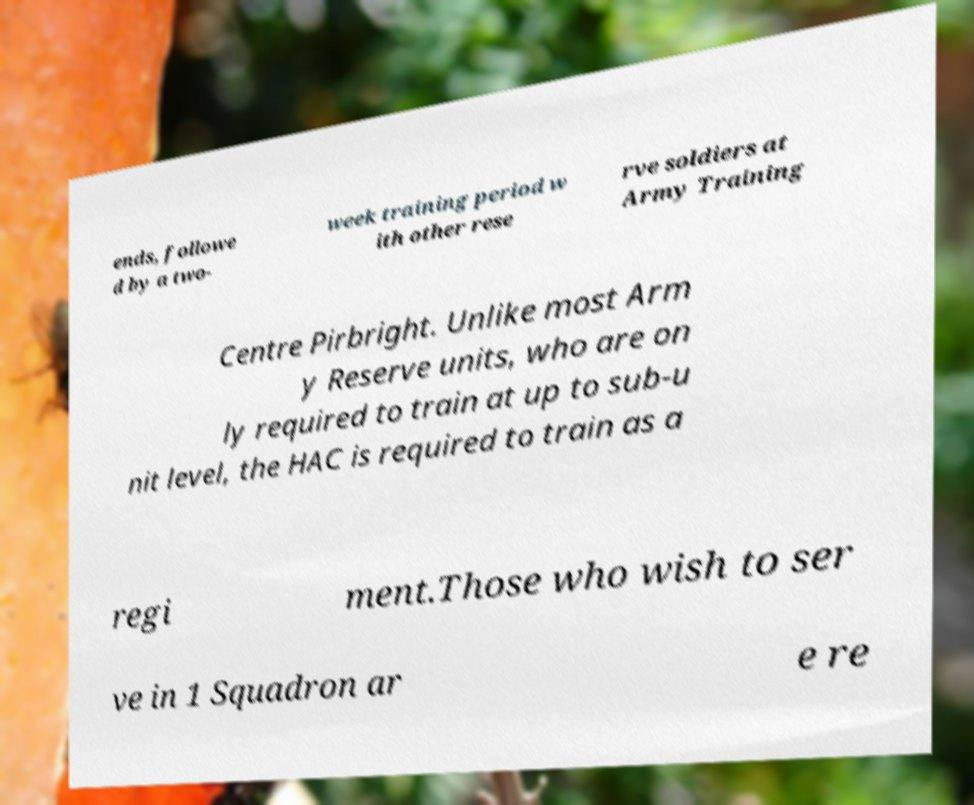Could you assist in decoding the text presented in this image and type it out clearly? ends, followe d by a two- week training period w ith other rese rve soldiers at Army Training Centre Pirbright. Unlike most Arm y Reserve units, who are on ly required to train at up to sub-u nit level, the HAC is required to train as a regi ment.Those who wish to ser ve in 1 Squadron ar e re 